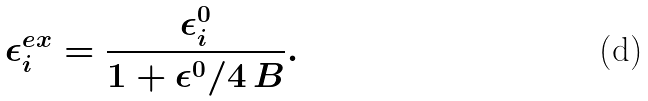Convert formula to latex. <formula><loc_0><loc_0><loc_500><loc_500>\epsilon _ { i } ^ { e x } = \frac { \epsilon _ { i } ^ { 0 } } { 1 + \epsilon ^ { 0 } / 4 \, B } .</formula> 